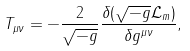Convert formula to latex. <formula><loc_0><loc_0><loc_500><loc_500>T _ { \mu \nu } = - { \frac { 2 } { \sqrt { - g } } } { \frac { \delta ( { \sqrt { - g } } { \mathcal { L } } _ { m } ) } { \delta g ^ { \mu \nu } } } ,</formula> 